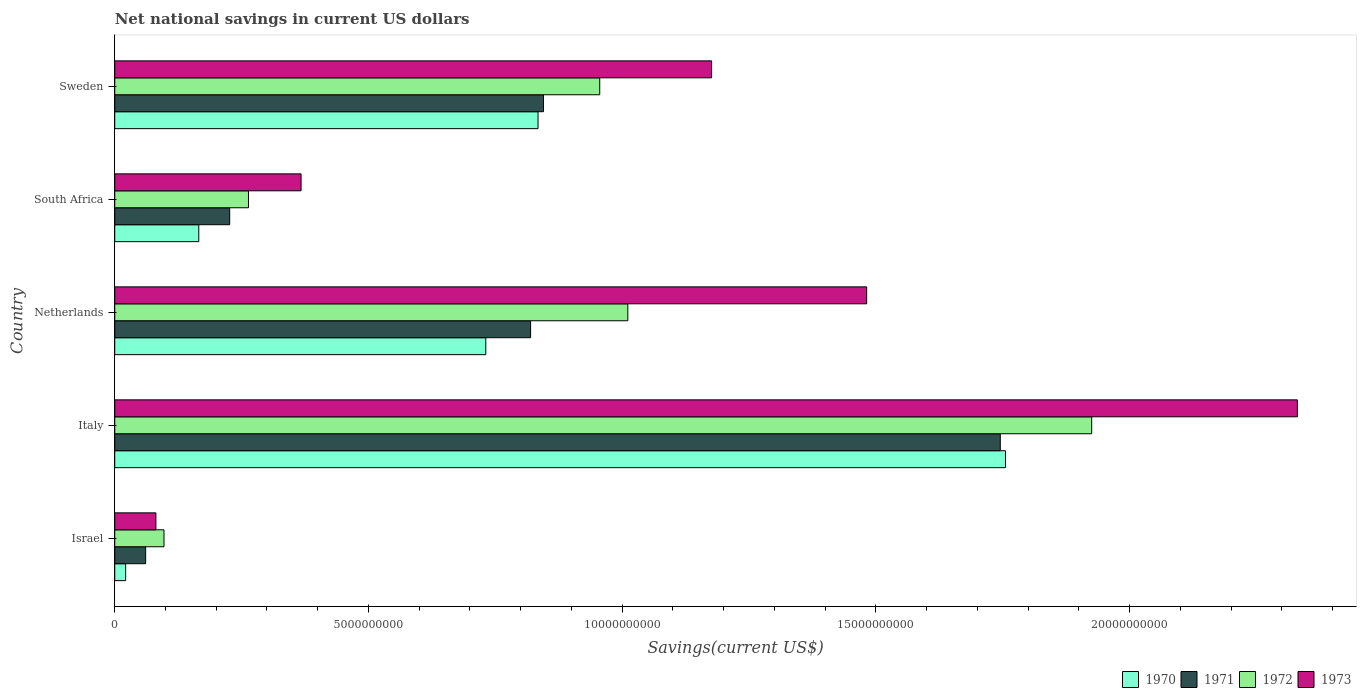How many bars are there on the 3rd tick from the bottom?
Keep it short and to the point. 4. In how many cases, is the number of bars for a given country not equal to the number of legend labels?
Ensure brevity in your answer.  0. What is the net national savings in 1970 in Italy?
Your response must be concise. 1.76e+1. Across all countries, what is the maximum net national savings in 1973?
Ensure brevity in your answer.  2.33e+1. Across all countries, what is the minimum net national savings in 1972?
Your answer should be compact. 9.71e+08. In which country was the net national savings in 1970 minimum?
Give a very brief answer. Israel. What is the total net national savings in 1971 in the graph?
Offer a very short reply. 3.70e+1. What is the difference between the net national savings in 1973 in Israel and that in Italy?
Provide a short and direct response. -2.25e+1. What is the difference between the net national savings in 1970 in Italy and the net national savings in 1973 in Netherlands?
Your answer should be compact. 2.74e+09. What is the average net national savings in 1972 per country?
Give a very brief answer. 8.51e+09. What is the difference between the net national savings in 1972 and net national savings in 1971 in South Africa?
Offer a very short reply. 3.70e+08. What is the ratio of the net national savings in 1971 in Italy to that in South Africa?
Make the answer very short. 7.7. Is the net national savings in 1973 in Italy less than that in South Africa?
Your answer should be compact. No. Is the difference between the net national savings in 1972 in Netherlands and Sweden greater than the difference between the net national savings in 1971 in Netherlands and Sweden?
Your answer should be compact. Yes. What is the difference between the highest and the second highest net national savings in 1971?
Your response must be concise. 9.00e+09. What is the difference between the highest and the lowest net national savings in 1972?
Your answer should be very brief. 1.83e+1. Is the sum of the net national savings in 1971 in Netherlands and South Africa greater than the maximum net national savings in 1972 across all countries?
Ensure brevity in your answer.  No. Is it the case that in every country, the sum of the net national savings in 1973 and net national savings in 1970 is greater than the sum of net national savings in 1971 and net national savings in 1972?
Give a very brief answer. No. Is it the case that in every country, the sum of the net national savings in 1972 and net national savings in 1970 is greater than the net national savings in 1973?
Provide a succinct answer. Yes. Are all the bars in the graph horizontal?
Ensure brevity in your answer.  Yes. Are the values on the major ticks of X-axis written in scientific E-notation?
Ensure brevity in your answer.  No. Does the graph contain any zero values?
Keep it short and to the point. No. Does the graph contain grids?
Provide a short and direct response. No. Where does the legend appear in the graph?
Provide a succinct answer. Bottom right. What is the title of the graph?
Give a very brief answer. Net national savings in current US dollars. What is the label or title of the X-axis?
Your response must be concise. Savings(current US$). What is the label or title of the Y-axis?
Give a very brief answer. Country. What is the Savings(current US$) of 1970 in Israel?
Your response must be concise. 2.15e+08. What is the Savings(current US$) of 1971 in Israel?
Your response must be concise. 6.09e+08. What is the Savings(current US$) of 1972 in Israel?
Offer a terse response. 9.71e+08. What is the Savings(current US$) in 1973 in Israel?
Your answer should be very brief. 8.11e+08. What is the Savings(current US$) in 1970 in Italy?
Make the answer very short. 1.76e+1. What is the Savings(current US$) in 1971 in Italy?
Give a very brief answer. 1.75e+1. What is the Savings(current US$) of 1972 in Italy?
Offer a very short reply. 1.93e+1. What is the Savings(current US$) in 1973 in Italy?
Offer a terse response. 2.33e+1. What is the Savings(current US$) of 1970 in Netherlands?
Offer a terse response. 7.31e+09. What is the Savings(current US$) of 1971 in Netherlands?
Your answer should be very brief. 8.20e+09. What is the Savings(current US$) of 1972 in Netherlands?
Your response must be concise. 1.01e+1. What is the Savings(current US$) of 1973 in Netherlands?
Your response must be concise. 1.48e+1. What is the Savings(current US$) of 1970 in South Africa?
Offer a very short reply. 1.66e+09. What is the Savings(current US$) in 1971 in South Africa?
Provide a succinct answer. 2.27e+09. What is the Savings(current US$) in 1972 in South Africa?
Provide a succinct answer. 2.64e+09. What is the Savings(current US$) of 1973 in South Africa?
Provide a short and direct response. 3.67e+09. What is the Savings(current US$) of 1970 in Sweden?
Keep it short and to the point. 8.34e+09. What is the Savings(current US$) of 1971 in Sweden?
Offer a terse response. 8.45e+09. What is the Savings(current US$) of 1972 in Sweden?
Your answer should be very brief. 9.56e+09. What is the Savings(current US$) in 1973 in Sweden?
Ensure brevity in your answer.  1.18e+1. Across all countries, what is the maximum Savings(current US$) of 1970?
Ensure brevity in your answer.  1.76e+1. Across all countries, what is the maximum Savings(current US$) of 1971?
Your response must be concise. 1.75e+1. Across all countries, what is the maximum Savings(current US$) in 1972?
Offer a very short reply. 1.93e+1. Across all countries, what is the maximum Savings(current US$) of 1973?
Your response must be concise. 2.33e+1. Across all countries, what is the minimum Savings(current US$) of 1970?
Make the answer very short. 2.15e+08. Across all countries, what is the minimum Savings(current US$) in 1971?
Offer a very short reply. 6.09e+08. Across all countries, what is the minimum Savings(current US$) in 1972?
Provide a short and direct response. 9.71e+08. Across all countries, what is the minimum Savings(current US$) of 1973?
Offer a terse response. 8.11e+08. What is the total Savings(current US$) in 1970 in the graph?
Ensure brevity in your answer.  3.51e+1. What is the total Savings(current US$) of 1971 in the graph?
Your response must be concise. 3.70e+1. What is the total Savings(current US$) of 1972 in the graph?
Make the answer very short. 4.25e+1. What is the total Savings(current US$) in 1973 in the graph?
Keep it short and to the point. 5.44e+1. What is the difference between the Savings(current US$) in 1970 in Israel and that in Italy?
Your response must be concise. -1.73e+1. What is the difference between the Savings(current US$) in 1971 in Israel and that in Italy?
Provide a succinct answer. -1.68e+1. What is the difference between the Savings(current US$) of 1972 in Israel and that in Italy?
Your answer should be very brief. -1.83e+1. What is the difference between the Savings(current US$) in 1973 in Israel and that in Italy?
Your answer should be very brief. -2.25e+1. What is the difference between the Savings(current US$) of 1970 in Israel and that in Netherlands?
Give a very brief answer. -7.10e+09. What is the difference between the Savings(current US$) of 1971 in Israel and that in Netherlands?
Your response must be concise. -7.59e+09. What is the difference between the Savings(current US$) in 1972 in Israel and that in Netherlands?
Provide a succinct answer. -9.14e+09. What is the difference between the Savings(current US$) in 1973 in Israel and that in Netherlands?
Offer a very short reply. -1.40e+1. What is the difference between the Savings(current US$) of 1970 in Israel and that in South Africa?
Give a very brief answer. -1.44e+09. What is the difference between the Savings(current US$) in 1971 in Israel and that in South Africa?
Provide a short and direct response. -1.66e+09. What is the difference between the Savings(current US$) in 1972 in Israel and that in South Africa?
Provide a short and direct response. -1.66e+09. What is the difference between the Savings(current US$) in 1973 in Israel and that in South Africa?
Provide a succinct answer. -2.86e+09. What is the difference between the Savings(current US$) in 1970 in Israel and that in Sweden?
Give a very brief answer. -8.13e+09. What is the difference between the Savings(current US$) of 1971 in Israel and that in Sweden?
Ensure brevity in your answer.  -7.84e+09. What is the difference between the Savings(current US$) in 1972 in Israel and that in Sweden?
Keep it short and to the point. -8.59e+09. What is the difference between the Savings(current US$) of 1973 in Israel and that in Sweden?
Keep it short and to the point. -1.10e+1. What is the difference between the Savings(current US$) in 1970 in Italy and that in Netherlands?
Provide a short and direct response. 1.02e+1. What is the difference between the Savings(current US$) of 1971 in Italy and that in Netherlands?
Give a very brief answer. 9.26e+09. What is the difference between the Savings(current US$) in 1972 in Italy and that in Netherlands?
Offer a terse response. 9.14e+09. What is the difference between the Savings(current US$) in 1973 in Italy and that in Netherlands?
Give a very brief answer. 8.49e+09. What is the difference between the Savings(current US$) in 1970 in Italy and that in South Africa?
Provide a succinct answer. 1.59e+1. What is the difference between the Savings(current US$) of 1971 in Italy and that in South Africa?
Give a very brief answer. 1.52e+1. What is the difference between the Savings(current US$) of 1972 in Italy and that in South Africa?
Keep it short and to the point. 1.66e+1. What is the difference between the Savings(current US$) of 1973 in Italy and that in South Africa?
Your response must be concise. 1.96e+1. What is the difference between the Savings(current US$) of 1970 in Italy and that in Sweden?
Make the answer very short. 9.21e+09. What is the difference between the Savings(current US$) of 1971 in Italy and that in Sweden?
Your answer should be compact. 9.00e+09. What is the difference between the Savings(current US$) in 1972 in Italy and that in Sweden?
Your response must be concise. 9.70e+09. What is the difference between the Savings(current US$) in 1973 in Italy and that in Sweden?
Ensure brevity in your answer.  1.15e+1. What is the difference between the Savings(current US$) of 1970 in Netherlands and that in South Africa?
Make the answer very short. 5.66e+09. What is the difference between the Savings(current US$) in 1971 in Netherlands and that in South Africa?
Make the answer very short. 5.93e+09. What is the difference between the Savings(current US$) of 1972 in Netherlands and that in South Africa?
Your response must be concise. 7.48e+09. What is the difference between the Savings(current US$) of 1973 in Netherlands and that in South Africa?
Give a very brief answer. 1.11e+1. What is the difference between the Savings(current US$) of 1970 in Netherlands and that in Sweden?
Offer a very short reply. -1.03e+09. What is the difference between the Savings(current US$) of 1971 in Netherlands and that in Sweden?
Your response must be concise. -2.53e+08. What is the difference between the Savings(current US$) of 1972 in Netherlands and that in Sweden?
Provide a short and direct response. 5.54e+08. What is the difference between the Savings(current US$) of 1973 in Netherlands and that in Sweden?
Keep it short and to the point. 3.06e+09. What is the difference between the Savings(current US$) in 1970 in South Africa and that in Sweden?
Offer a very short reply. -6.69e+09. What is the difference between the Savings(current US$) in 1971 in South Africa and that in Sweden?
Keep it short and to the point. -6.18e+09. What is the difference between the Savings(current US$) in 1972 in South Africa and that in Sweden?
Your answer should be very brief. -6.92e+09. What is the difference between the Savings(current US$) of 1973 in South Africa and that in Sweden?
Provide a succinct answer. -8.09e+09. What is the difference between the Savings(current US$) of 1970 in Israel and the Savings(current US$) of 1971 in Italy?
Keep it short and to the point. -1.72e+1. What is the difference between the Savings(current US$) of 1970 in Israel and the Savings(current US$) of 1972 in Italy?
Your response must be concise. -1.90e+1. What is the difference between the Savings(current US$) of 1970 in Israel and the Savings(current US$) of 1973 in Italy?
Offer a very short reply. -2.31e+1. What is the difference between the Savings(current US$) in 1971 in Israel and the Savings(current US$) in 1972 in Italy?
Provide a succinct answer. -1.86e+1. What is the difference between the Savings(current US$) of 1971 in Israel and the Savings(current US$) of 1973 in Italy?
Your answer should be very brief. -2.27e+1. What is the difference between the Savings(current US$) of 1972 in Israel and the Savings(current US$) of 1973 in Italy?
Make the answer very short. -2.23e+1. What is the difference between the Savings(current US$) in 1970 in Israel and the Savings(current US$) in 1971 in Netherlands?
Provide a succinct answer. -7.98e+09. What is the difference between the Savings(current US$) of 1970 in Israel and the Savings(current US$) of 1972 in Netherlands?
Ensure brevity in your answer.  -9.90e+09. What is the difference between the Savings(current US$) in 1970 in Israel and the Savings(current US$) in 1973 in Netherlands?
Your response must be concise. -1.46e+1. What is the difference between the Savings(current US$) of 1971 in Israel and the Savings(current US$) of 1972 in Netherlands?
Your answer should be compact. -9.50e+09. What is the difference between the Savings(current US$) of 1971 in Israel and the Savings(current US$) of 1973 in Netherlands?
Make the answer very short. -1.42e+1. What is the difference between the Savings(current US$) of 1972 in Israel and the Savings(current US$) of 1973 in Netherlands?
Ensure brevity in your answer.  -1.38e+1. What is the difference between the Savings(current US$) in 1970 in Israel and the Savings(current US$) in 1971 in South Africa?
Ensure brevity in your answer.  -2.05e+09. What is the difference between the Savings(current US$) in 1970 in Israel and the Savings(current US$) in 1972 in South Africa?
Ensure brevity in your answer.  -2.42e+09. What is the difference between the Savings(current US$) in 1970 in Israel and the Savings(current US$) in 1973 in South Africa?
Make the answer very short. -3.46e+09. What is the difference between the Savings(current US$) of 1971 in Israel and the Savings(current US$) of 1972 in South Africa?
Ensure brevity in your answer.  -2.03e+09. What is the difference between the Savings(current US$) in 1971 in Israel and the Savings(current US$) in 1973 in South Africa?
Provide a short and direct response. -3.06e+09. What is the difference between the Savings(current US$) of 1972 in Israel and the Savings(current US$) of 1973 in South Africa?
Give a very brief answer. -2.70e+09. What is the difference between the Savings(current US$) of 1970 in Israel and the Savings(current US$) of 1971 in Sweden?
Provide a succinct answer. -8.23e+09. What is the difference between the Savings(current US$) in 1970 in Israel and the Savings(current US$) in 1972 in Sweden?
Provide a short and direct response. -9.34e+09. What is the difference between the Savings(current US$) in 1970 in Israel and the Savings(current US$) in 1973 in Sweden?
Provide a short and direct response. -1.15e+1. What is the difference between the Savings(current US$) in 1971 in Israel and the Savings(current US$) in 1972 in Sweden?
Provide a short and direct response. -8.95e+09. What is the difference between the Savings(current US$) in 1971 in Israel and the Savings(current US$) in 1973 in Sweden?
Ensure brevity in your answer.  -1.12e+1. What is the difference between the Savings(current US$) in 1972 in Israel and the Savings(current US$) in 1973 in Sweden?
Your answer should be compact. -1.08e+1. What is the difference between the Savings(current US$) in 1970 in Italy and the Savings(current US$) in 1971 in Netherlands?
Provide a succinct answer. 9.36e+09. What is the difference between the Savings(current US$) in 1970 in Italy and the Savings(current US$) in 1972 in Netherlands?
Provide a short and direct response. 7.44e+09. What is the difference between the Savings(current US$) of 1970 in Italy and the Savings(current US$) of 1973 in Netherlands?
Provide a short and direct response. 2.74e+09. What is the difference between the Savings(current US$) of 1971 in Italy and the Savings(current US$) of 1972 in Netherlands?
Provide a short and direct response. 7.34e+09. What is the difference between the Savings(current US$) of 1971 in Italy and the Savings(current US$) of 1973 in Netherlands?
Provide a succinct answer. 2.63e+09. What is the difference between the Savings(current US$) of 1972 in Italy and the Savings(current US$) of 1973 in Netherlands?
Ensure brevity in your answer.  4.44e+09. What is the difference between the Savings(current US$) of 1970 in Italy and the Savings(current US$) of 1971 in South Africa?
Offer a very short reply. 1.53e+1. What is the difference between the Savings(current US$) of 1970 in Italy and the Savings(current US$) of 1972 in South Africa?
Offer a terse response. 1.49e+1. What is the difference between the Savings(current US$) of 1970 in Italy and the Savings(current US$) of 1973 in South Africa?
Provide a succinct answer. 1.39e+1. What is the difference between the Savings(current US$) of 1971 in Italy and the Savings(current US$) of 1972 in South Africa?
Give a very brief answer. 1.48e+1. What is the difference between the Savings(current US$) in 1971 in Italy and the Savings(current US$) in 1973 in South Africa?
Your response must be concise. 1.38e+1. What is the difference between the Savings(current US$) in 1972 in Italy and the Savings(current US$) in 1973 in South Africa?
Make the answer very short. 1.56e+1. What is the difference between the Savings(current US$) in 1970 in Italy and the Savings(current US$) in 1971 in Sweden?
Provide a succinct answer. 9.11e+09. What is the difference between the Savings(current US$) of 1970 in Italy and the Savings(current US$) of 1972 in Sweden?
Give a very brief answer. 8.00e+09. What is the difference between the Savings(current US$) in 1970 in Italy and the Savings(current US$) in 1973 in Sweden?
Provide a succinct answer. 5.79e+09. What is the difference between the Savings(current US$) of 1971 in Italy and the Savings(current US$) of 1972 in Sweden?
Your response must be concise. 7.89e+09. What is the difference between the Savings(current US$) of 1971 in Italy and the Savings(current US$) of 1973 in Sweden?
Offer a very short reply. 5.69e+09. What is the difference between the Savings(current US$) in 1972 in Italy and the Savings(current US$) in 1973 in Sweden?
Provide a short and direct response. 7.49e+09. What is the difference between the Savings(current US$) of 1970 in Netherlands and the Savings(current US$) of 1971 in South Africa?
Your answer should be compact. 5.05e+09. What is the difference between the Savings(current US$) in 1970 in Netherlands and the Savings(current US$) in 1972 in South Africa?
Ensure brevity in your answer.  4.68e+09. What is the difference between the Savings(current US$) of 1970 in Netherlands and the Savings(current US$) of 1973 in South Africa?
Ensure brevity in your answer.  3.64e+09. What is the difference between the Savings(current US$) of 1971 in Netherlands and the Savings(current US$) of 1972 in South Africa?
Ensure brevity in your answer.  5.56e+09. What is the difference between the Savings(current US$) of 1971 in Netherlands and the Savings(current US$) of 1973 in South Africa?
Your response must be concise. 4.52e+09. What is the difference between the Savings(current US$) in 1972 in Netherlands and the Savings(current US$) in 1973 in South Africa?
Your answer should be compact. 6.44e+09. What is the difference between the Savings(current US$) of 1970 in Netherlands and the Savings(current US$) of 1971 in Sweden?
Provide a succinct answer. -1.14e+09. What is the difference between the Savings(current US$) of 1970 in Netherlands and the Savings(current US$) of 1972 in Sweden?
Ensure brevity in your answer.  -2.25e+09. What is the difference between the Savings(current US$) in 1970 in Netherlands and the Savings(current US$) in 1973 in Sweden?
Make the answer very short. -4.45e+09. What is the difference between the Savings(current US$) of 1971 in Netherlands and the Savings(current US$) of 1972 in Sweden?
Offer a very short reply. -1.36e+09. What is the difference between the Savings(current US$) of 1971 in Netherlands and the Savings(current US$) of 1973 in Sweden?
Provide a short and direct response. -3.57e+09. What is the difference between the Savings(current US$) in 1972 in Netherlands and the Savings(current US$) in 1973 in Sweden?
Your answer should be compact. -1.65e+09. What is the difference between the Savings(current US$) in 1970 in South Africa and the Savings(current US$) in 1971 in Sweden?
Ensure brevity in your answer.  -6.79e+09. What is the difference between the Savings(current US$) of 1970 in South Africa and the Savings(current US$) of 1972 in Sweden?
Provide a succinct answer. -7.90e+09. What is the difference between the Savings(current US$) in 1970 in South Africa and the Savings(current US$) in 1973 in Sweden?
Offer a very short reply. -1.01e+1. What is the difference between the Savings(current US$) in 1971 in South Africa and the Savings(current US$) in 1972 in Sweden?
Give a very brief answer. -7.29e+09. What is the difference between the Savings(current US$) of 1971 in South Africa and the Savings(current US$) of 1973 in Sweden?
Provide a short and direct response. -9.50e+09. What is the difference between the Savings(current US$) in 1972 in South Africa and the Savings(current US$) in 1973 in Sweden?
Provide a succinct answer. -9.13e+09. What is the average Savings(current US$) of 1970 per country?
Your answer should be compact. 7.02e+09. What is the average Savings(current US$) of 1971 per country?
Your answer should be compact. 7.39e+09. What is the average Savings(current US$) of 1972 per country?
Provide a succinct answer. 8.51e+09. What is the average Savings(current US$) of 1973 per country?
Offer a terse response. 1.09e+1. What is the difference between the Savings(current US$) of 1970 and Savings(current US$) of 1971 in Israel?
Keep it short and to the point. -3.94e+08. What is the difference between the Savings(current US$) in 1970 and Savings(current US$) in 1972 in Israel?
Make the answer very short. -7.56e+08. What is the difference between the Savings(current US$) of 1970 and Savings(current US$) of 1973 in Israel?
Your answer should be compact. -5.96e+08. What is the difference between the Savings(current US$) in 1971 and Savings(current US$) in 1972 in Israel?
Ensure brevity in your answer.  -3.62e+08. What is the difference between the Savings(current US$) of 1971 and Savings(current US$) of 1973 in Israel?
Your answer should be compact. -2.02e+08. What is the difference between the Savings(current US$) of 1972 and Savings(current US$) of 1973 in Israel?
Give a very brief answer. 1.60e+08. What is the difference between the Savings(current US$) of 1970 and Savings(current US$) of 1971 in Italy?
Make the answer very short. 1.03e+08. What is the difference between the Savings(current US$) of 1970 and Savings(current US$) of 1972 in Italy?
Keep it short and to the point. -1.70e+09. What is the difference between the Savings(current US$) of 1970 and Savings(current US$) of 1973 in Italy?
Offer a very short reply. -5.75e+09. What is the difference between the Savings(current US$) of 1971 and Savings(current US$) of 1972 in Italy?
Your answer should be compact. -1.80e+09. What is the difference between the Savings(current US$) of 1971 and Savings(current US$) of 1973 in Italy?
Your response must be concise. -5.86e+09. What is the difference between the Savings(current US$) in 1972 and Savings(current US$) in 1973 in Italy?
Offer a terse response. -4.05e+09. What is the difference between the Savings(current US$) of 1970 and Savings(current US$) of 1971 in Netherlands?
Give a very brief answer. -8.83e+08. What is the difference between the Savings(current US$) of 1970 and Savings(current US$) of 1972 in Netherlands?
Ensure brevity in your answer.  -2.80e+09. What is the difference between the Savings(current US$) in 1970 and Savings(current US$) in 1973 in Netherlands?
Provide a short and direct response. -7.51e+09. What is the difference between the Savings(current US$) in 1971 and Savings(current US$) in 1972 in Netherlands?
Make the answer very short. -1.92e+09. What is the difference between the Savings(current US$) of 1971 and Savings(current US$) of 1973 in Netherlands?
Provide a short and direct response. -6.62e+09. What is the difference between the Savings(current US$) of 1972 and Savings(current US$) of 1973 in Netherlands?
Provide a short and direct response. -4.71e+09. What is the difference between the Savings(current US$) of 1970 and Savings(current US$) of 1971 in South Africa?
Your answer should be compact. -6.09e+08. What is the difference between the Savings(current US$) in 1970 and Savings(current US$) in 1972 in South Africa?
Provide a short and direct response. -9.79e+08. What is the difference between the Savings(current US$) of 1970 and Savings(current US$) of 1973 in South Africa?
Your response must be concise. -2.02e+09. What is the difference between the Savings(current US$) in 1971 and Savings(current US$) in 1972 in South Africa?
Offer a terse response. -3.70e+08. What is the difference between the Savings(current US$) in 1971 and Savings(current US$) in 1973 in South Africa?
Your response must be concise. -1.41e+09. What is the difference between the Savings(current US$) of 1972 and Savings(current US$) of 1973 in South Africa?
Keep it short and to the point. -1.04e+09. What is the difference between the Savings(current US$) in 1970 and Savings(current US$) in 1971 in Sweden?
Make the answer very short. -1.07e+08. What is the difference between the Savings(current US$) in 1970 and Savings(current US$) in 1972 in Sweden?
Make the answer very short. -1.22e+09. What is the difference between the Savings(current US$) of 1970 and Savings(current US$) of 1973 in Sweden?
Your answer should be very brief. -3.42e+09. What is the difference between the Savings(current US$) of 1971 and Savings(current US$) of 1972 in Sweden?
Your answer should be compact. -1.11e+09. What is the difference between the Savings(current US$) of 1971 and Savings(current US$) of 1973 in Sweden?
Provide a short and direct response. -3.31e+09. What is the difference between the Savings(current US$) in 1972 and Savings(current US$) in 1973 in Sweden?
Offer a very short reply. -2.20e+09. What is the ratio of the Savings(current US$) in 1970 in Israel to that in Italy?
Make the answer very short. 0.01. What is the ratio of the Savings(current US$) in 1971 in Israel to that in Italy?
Your response must be concise. 0.03. What is the ratio of the Savings(current US$) of 1972 in Israel to that in Italy?
Keep it short and to the point. 0.05. What is the ratio of the Savings(current US$) in 1973 in Israel to that in Italy?
Keep it short and to the point. 0.03. What is the ratio of the Savings(current US$) of 1970 in Israel to that in Netherlands?
Offer a terse response. 0.03. What is the ratio of the Savings(current US$) in 1971 in Israel to that in Netherlands?
Your answer should be very brief. 0.07. What is the ratio of the Savings(current US$) in 1972 in Israel to that in Netherlands?
Keep it short and to the point. 0.1. What is the ratio of the Savings(current US$) of 1973 in Israel to that in Netherlands?
Your answer should be very brief. 0.05. What is the ratio of the Savings(current US$) in 1970 in Israel to that in South Africa?
Offer a terse response. 0.13. What is the ratio of the Savings(current US$) in 1971 in Israel to that in South Africa?
Make the answer very short. 0.27. What is the ratio of the Savings(current US$) in 1972 in Israel to that in South Africa?
Your answer should be compact. 0.37. What is the ratio of the Savings(current US$) of 1973 in Israel to that in South Africa?
Provide a short and direct response. 0.22. What is the ratio of the Savings(current US$) in 1970 in Israel to that in Sweden?
Offer a very short reply. 0.03. What is the ratio of the Savings(current US$) in 1971 in Israel to that in Sweden?
Ensure brevity in your answer.  0.07. What is the ratio of the Savings(current US$) of 1972 in Israel to that in Sweden?
Provide a succinct answer. 0.1. What is the ratio of the Savings(current US$) of 1973 in Israel to that in Sweden?
Ensure brevity in your answer.  0.07. What is the ratio of the Savings(current US$) in 1970 in Italy to that in Netherlands?
Your answer should be very brief. 2.4. What is the ratio of the Savings(current US$) of 1971 in Italy to that in Netherlands?
Your response must be concise. 2.13. What is the ratio of the Savings(current US$) of 1972 in Italy to that in Netherlands?
Offer a very short reply. 1.9. What is the ratio of the Savings(current US$) of 1973 in Italy to that in Netherlands?
Make the answer very short. 1.57. What is the ratio of the Savings(current US$) in 1970 in Italy to that in South Africa?
Provide a succinct answer. 10.6. What is the ratio of the Savings(current US$) of 1971 in Italy to that in South Africa?
Make the answer very short. 7.7. What is the ratio of the Savings(current US$) of 1972 in Italy to that in South Africa?
Provide a succinct answer. 7.31. What is the ratio of the Savings(current US$) in 1973 in Italy to that in South Africa?
Provide a short and direct response. 6.35. What is the ratio of the Savings(current US$) in 1970 in Italy to that in Sweden?
Provide a short and direct response. 2.1. What is the ratio of the Savings(current US$) of 1971 in Italy to that in Sweden?
Offer a terse response. 2.07. What is the ratio of the Savings(current US$) in 1972 in Italy to that in Sweden?
Ensure brevity in your answer.  2.01. What is the ratio of the Savings(current US$) in 1973 in Italy to that in Sweden?
Offer a terse response. 1.98. What is the ratio of the Savings(current US$) of 1970 in Netherlands to that in South Africa?
Offer a terse response. 4.42. What is the ratio of the Savings(current US$) in 1971 in Netherlands to that in South Africa?
Give a very brief answer. 3.62. What is the ratio of the Savings(current US$) of 1972 in Netherlands to that in South Africa?
Provide a succinct answer. 3.84. What is the ratio of the Savings(current US$) of 1973 in Netherlands to that in South Africa?
Provide a succinct answer. 4.04. What is the ratio of the Savings(current US$) of 1970 in Netherlands to that in Sweden?
Offer a very short reply. 0.88. What is the ratio of the Savings(current US$) of 1971 in Netherlands to that in Sweden?
Offer a terse response. 0.97. What is the ratio of the Savings(current US$) in 1972 in Netherlands to that in Sweden?
Make the answer very short. 1.06. What is the ratio of the Savings(current US$) of 1973 in Netherlands to that in Sweden?
Provide a short and direct response. 1.26. What is the ratio of the Savings(current US$) in 1970 in South Africa to that in Sweden?
Ensure brevity in your answer.  0.2. What is the ratio of the Savings(current US$) of 1971 in South Africa to that in Sweden?
Make the answer very short. 0.27. What is the ratio of the Savings(current US$) of 1972 in South Africa to that in Sweden?
Keep it short and to the point. 0.28. What is the ratio of the Savings(current US$) in 1973 in South Africa to that in Sweden?
Keep it short and to the point. 0.31. What is the difference between the highest and the second highest Savings(current US$) of 1970?
Offer a terse response. 9.21e+09. What is the difference between the highest and the second highest Savings(current US$) of 1971?
Make the answer very short. 9.00e+09. What is the difference between the highest and the second highest Savings(current US$) in 1972?
Provide a succinct answer. 9.14e+09. What is the difference between the highest and the second highest Savings(current US$) in 1973?
Your response must be concise. 8.49e+09. What is the difference between the highest and the lowest Savings(current US$) of 1970?
Ensure brevity in your answer.  1.73e+1. What is the difference between the highest and the lowest Savings(current US$) of 1971?
Your answer should be very brief. 1.68e+1. What is the difference between the highest and the lowest Savings(current US$) in 1972?
Keep it short and to the point. 1.83e+1. What is the difference between the highest and the lowest Savings(current US$) in 1973?
Provide a succinct answer. 2.25e+1. 